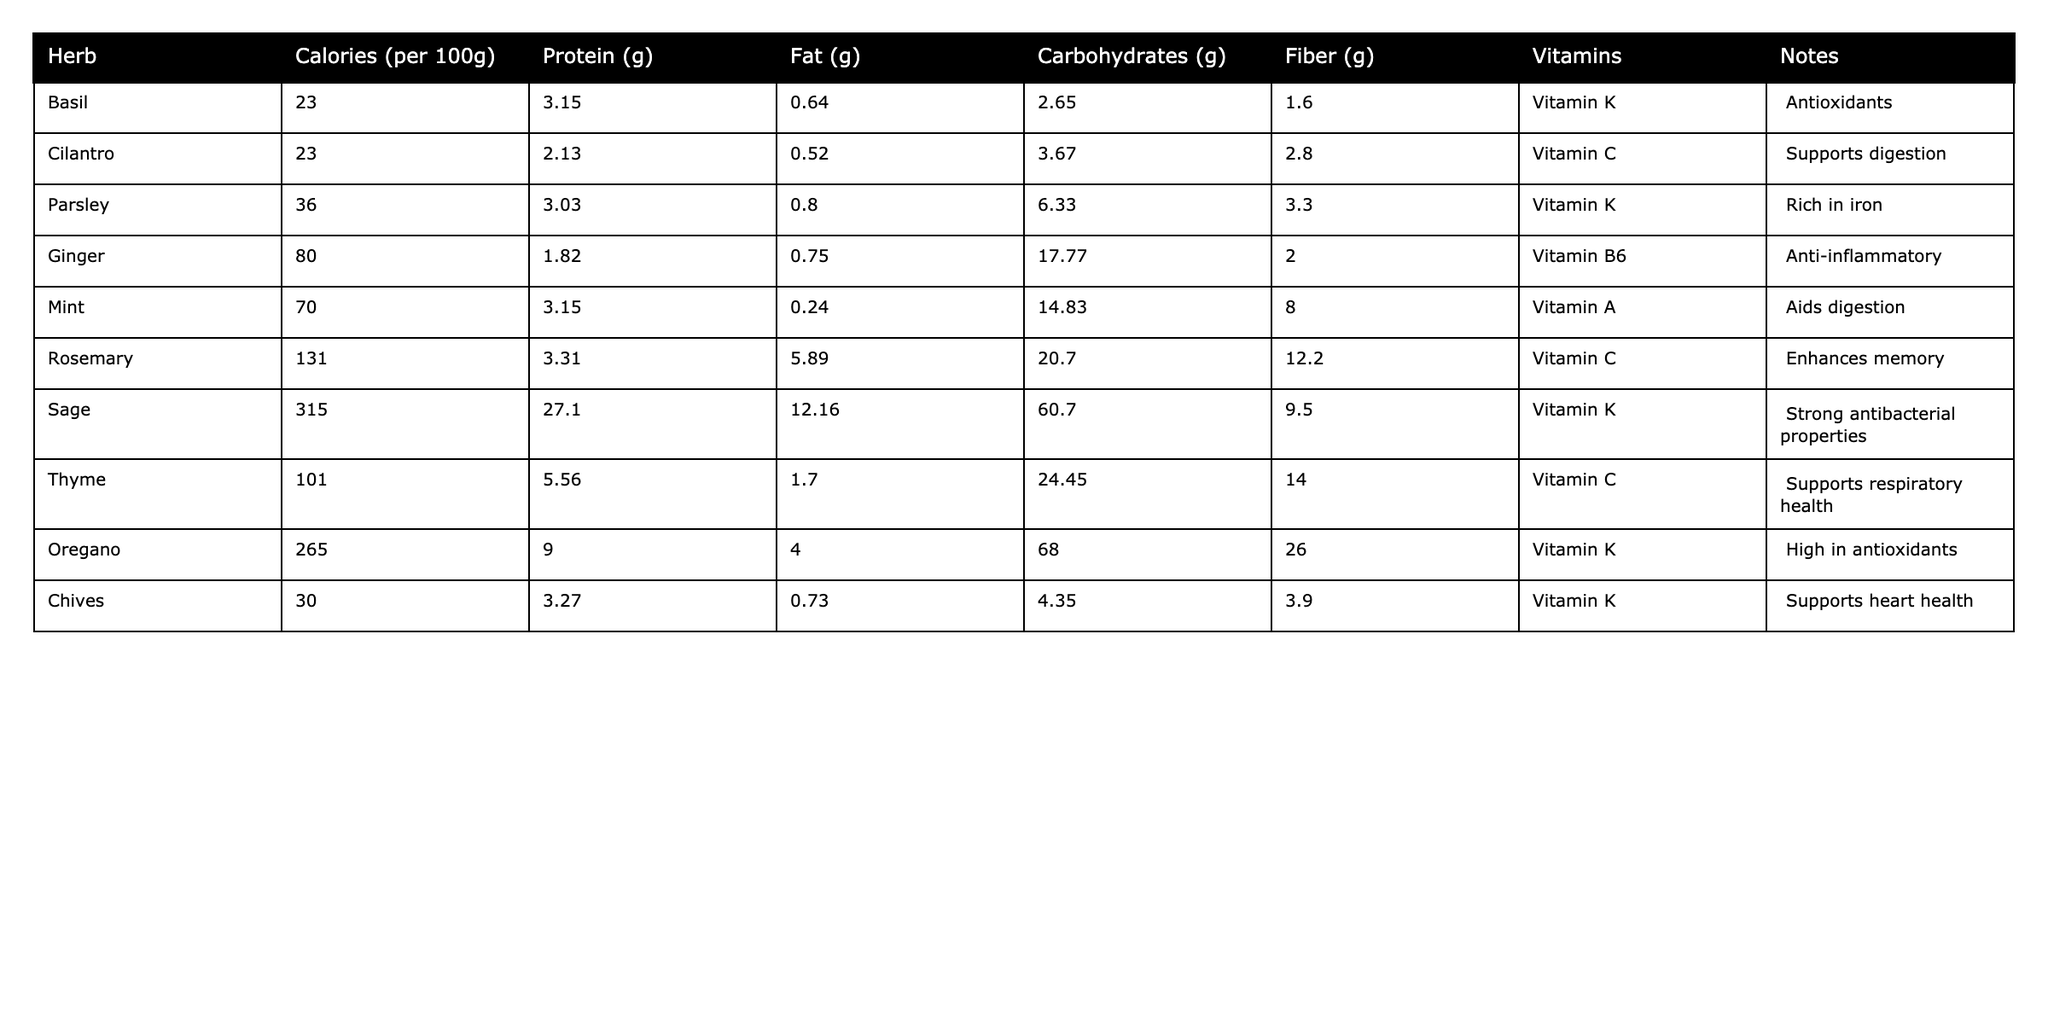What is the highest calorie herb in the table? By inspecting the calorie values in the "Calories (per 100g)" column, we can see that Sage has the highest amount at 315 calories per 100g.
Answer: Sage Which herb has the lowest amount of carbohydrates? The "Carbohydrates (g)" column shows that Basil has the lowest amount with 2.65g per 100g.
Answer: Basil True or False: Oregano contains more protein than Ginger. In the "Protein (g)" column, Oregano has 9.0g, while Ginger has only 1.82g, making the statement true.
Answer: True What is the total amount of fat in Mint and Chives combined? Adding the fat content from Mint (0.24g) and Chives (0.73g) gives a total of 0.24 + 0.73 = 0.97g of fat.
Answer: 0.97g Which herb contains the most fiber? Examining the "Fiber (g)" column, Oregano has the highest fiber content at 26.0g per 100g.
Answer: Oregano What is the average calorie content of the herbs listed? The total calorie content sums to 315 + 131 + 265 + 80 + 70 + 36 + 23 + 23 + 36 + 101 = 1,066 calories across 10 herbs, so the average is 1066 / 10 = 106.6.
Answer: 106.6 Which herb has the highest content of Vitamin K? Looking at the "Vitamins" column, both Sage and Oregano are highlighted as high in Vitamin K, but Sage also has notable antibacterial properties. Thus, Sage may be interpreted as having a more significant impact overall.
Answer: Sage What is the difference in protein content between Rosemary and Thyme? The protein content of Rosemary is 3.31g, while Thyme has 5.56g. The difference is 5.56 - 3.31 = 2.25g.
Answer: 2.25g Which two herbs have the highest fiber content? By reviewing the "Fiber (g)" column, Oregano has 26.0g, and Rosemary has 12.2g, making them the two herbs with the highest fiber content.
Answer: Oregano and Rosemary Is the combined fat content of Basil and Cilantro greater than that of Mint? The fat content for Basil is 0.64g and for Cilantro is 0.52g. Their combined total is 0.64 + 0.52 = 1.16g, which is greater than Mint's 0.24g.
Answer: Yes 